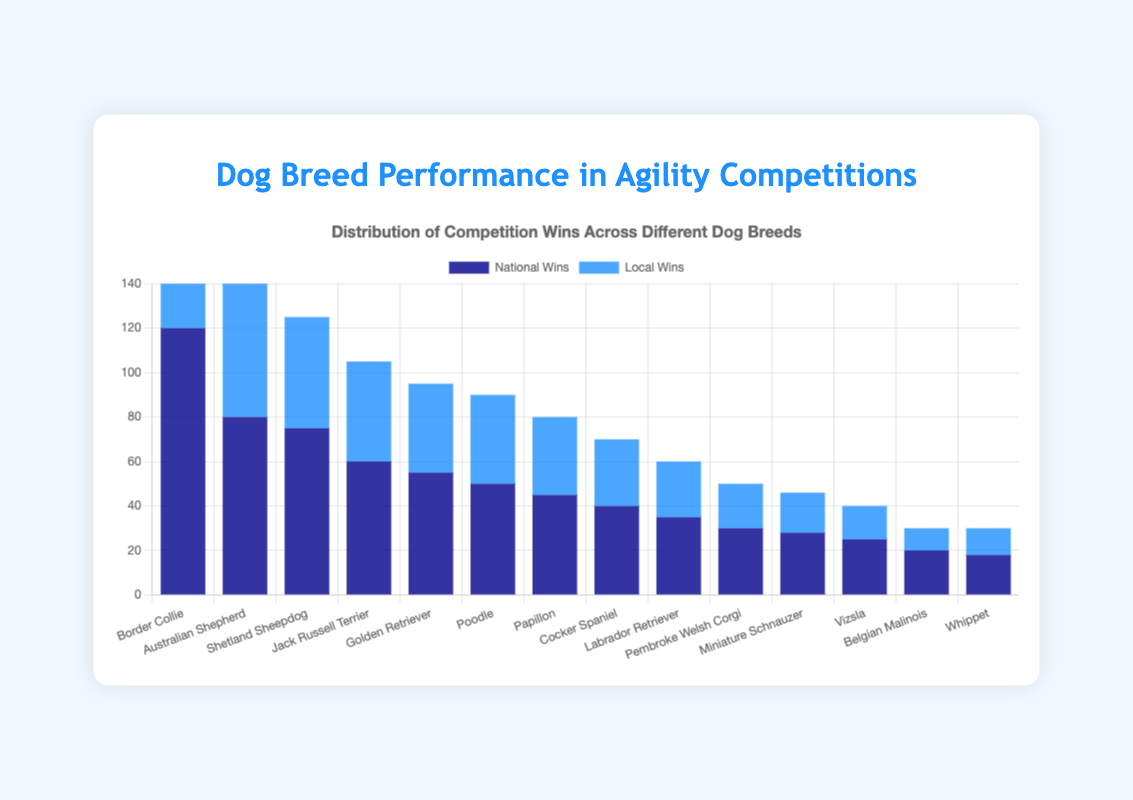Which dog breed has the highest number of wins in national events? By looking at the bar chart, the height of the dark blue bar is the tallest for the "Border Collie" breed, indicating it has the highest number of wins in national events.
Answer: Border Collie How many total wins does the Poodle breed have in both national and local events? To find the total wins for the Poodle breed, add the wins from national events (50) and local events (40): 50 + 40 = 90.
Answer: 90 Which breed has more local wins, Shetland Sheepdog or Jack Russell Terrier? By comparing the height of the blue bars, we see that the Shetland Sheepdog has a blue bar with a value of 50, while the Jack Russell Terrier has a blue bar with a value of 45. Thus, the Shetland Sheepdog has more local wins.
Answer: Shetland Sheepdog What is the difference in local wins between the Papillon and Cocker Spaniel breeds? To find the difference, subtract the number of local wins for the Cocker Spaniel (30) from the number of local wins for the Papillon (35): 35 - 30 = 5.
Answer: 5 What is the average number of national wins among the top four breeds? First, identify the top four breeds based on national wins: Border Collie (120), Australian Shepherd (80), Shetland Sheepdog (75), and Jack Russell Terrier (60). Then, calculate the average: (120 + 80 + 75 + 60) / 4 = 83.75.
Answer: 83.75 Which breed has the smallest difference between national and local wins? Calculate the difference between national and local wins for each breed and find the smallest difference. Here, the differences are: Border Collie (25), Australian Shepherd (10), Shetland Sheepdog (25), Jack Russell Terrier (15), Golden Retriever (15), Poodle (10), Papillon (10), Cocker Spaniel (10), Labrador Retriever (10), Pembroke Welsh Corgi (10), Miniature Schnauzer (10), Vizsla (10), Belgian Malinois (10), Whippet (6). The smallest difference is 6 for the Whippet.
Answer: Whippet Among the breeds listed, how many have more than 50 national wins? Check which breeds have dark blue bars representing national wins larger than 50: Border Collie (120), Australian Shepherd (80), Shetland Sheepdog (75), Jack Russell Terrier (60), and Golden Retriever (55). There are 5 breeds with more than 50 national wins.
Answer: 5 Which breed has more national wins than local wins but less than 50 national wins? Look at the data and find breeds where the national wins are higher than local wins and national wins are less than 50: The breed meeting these conditions is Belgian Malinois (20 national wins, 10 local wins).
Answer: Belgian Malinois 